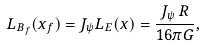Convert formula to latex. <formula><loc_0><loc_0><loc_500><loc_500>L _ { B _ { f } } ( x _ { f } ) = J _ { \psi } L _ { E } ( x ) = \frac { J _ { \psi } \, R } { 1 6 \pi G } ,</formula> 